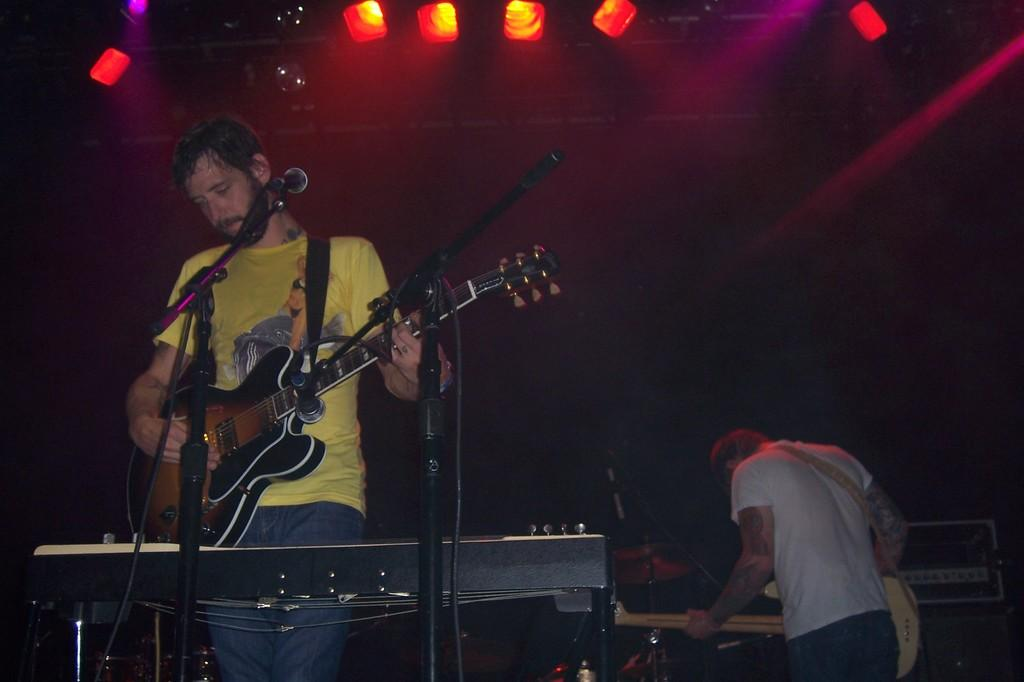What is the person wearing yellow doing in the image? The person wearing yellow is playing a guitar in the image. What can be seen near the person playing the guitar? The person wearing yellow is in front of a microphone. Can you describe the other person in the image? There is another person in the background of the image, and they are holding a guitar. How many ducks are visible in the image? There are no ducks present in the image. What type of crowd can be seen gathering around the person playing the guitar? There is no crowd visible in the image; it only shows the person wearing yellow playing a guitar and another person in the background holding a guitar. 